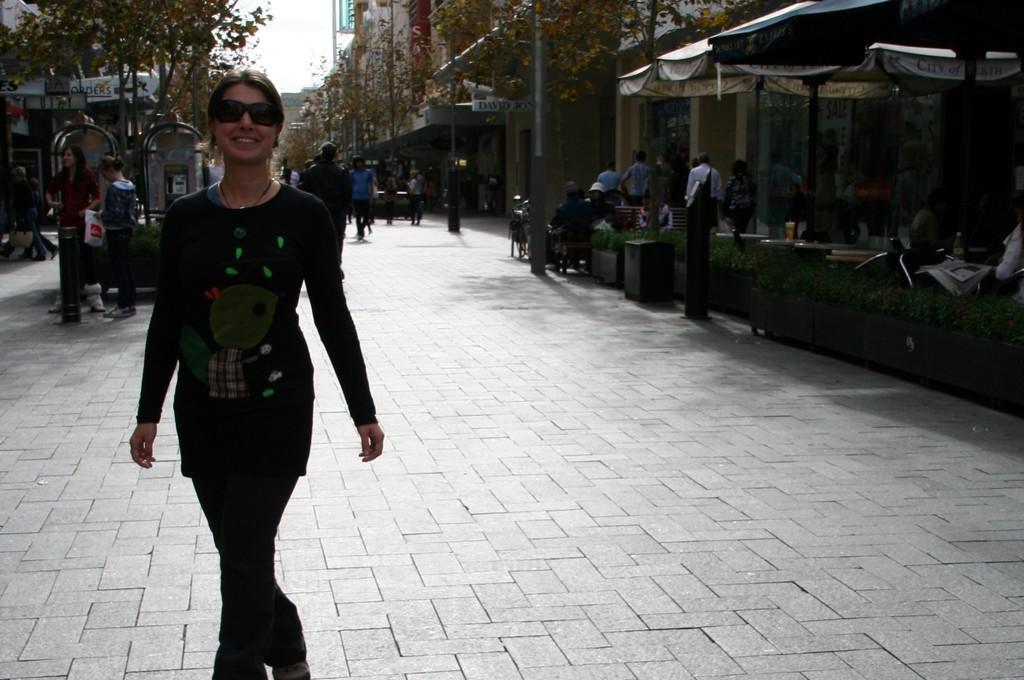Describe this image in one or two sentences. In this image we can see a group of people standing on the ground. We can also see some people under a tent, some plants, a board, some buildings, the sign boards, poles and the sky which looks cloudy. 